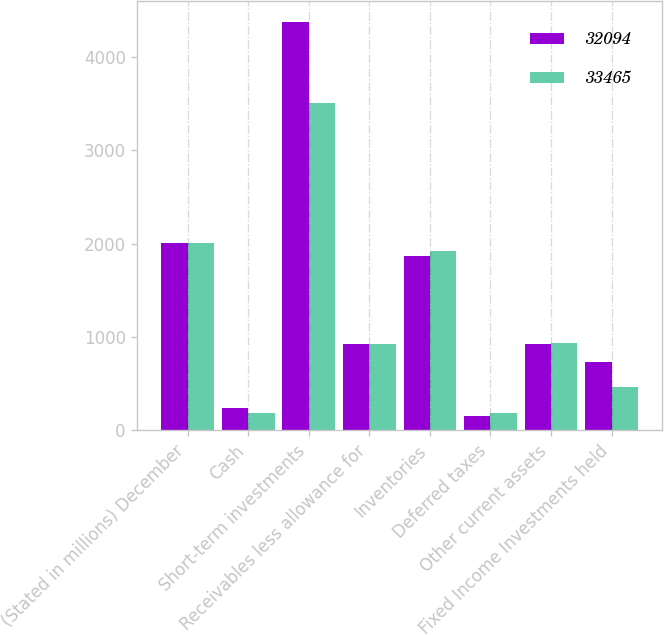Convert chart. <chart><loc_0><loc_0><loc_500><loc_500><stacked_bar_chart><ecel><fcel>(Stated in millions) December<fcel>Cash<fcel>Short-term investments<fcel>Receivables less allowance for<fcel>Inventories<fcel>Deferred taxes<fcel>Other current assets<fcel>Fixed Income Investments held<nl><fcel>32094<fcel>2009<fcel>243<fcel>4373<fcel>929.5<fcel>1866<fcel>154<fcel>926<fcel>738<nl><fcel>33465<fcel>2008<fcel>189<fcel>3503<fcel>929.5<fcel>1919<fcel>184<fcel>933<fcel>470<nl></chart> 